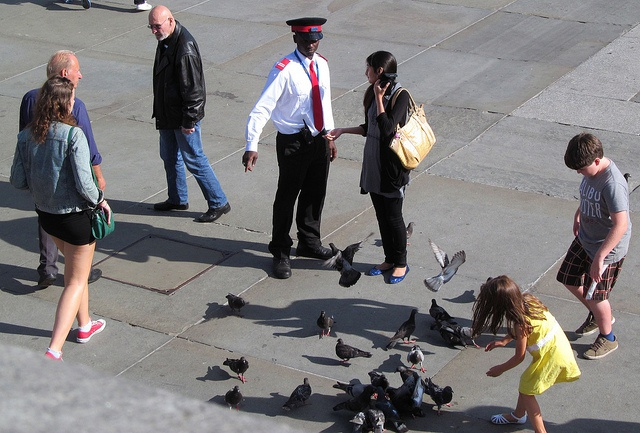Describe the objects in this image and their specific colors. I can see people in black, white, and darkgray tones, people in black, gray, and lightgray tones, people in black, gray, darkgray, and lightgray tones, people in black, darkgray, gray, and maroon tones, and people in black, gray, and darkgray tones in this image. 